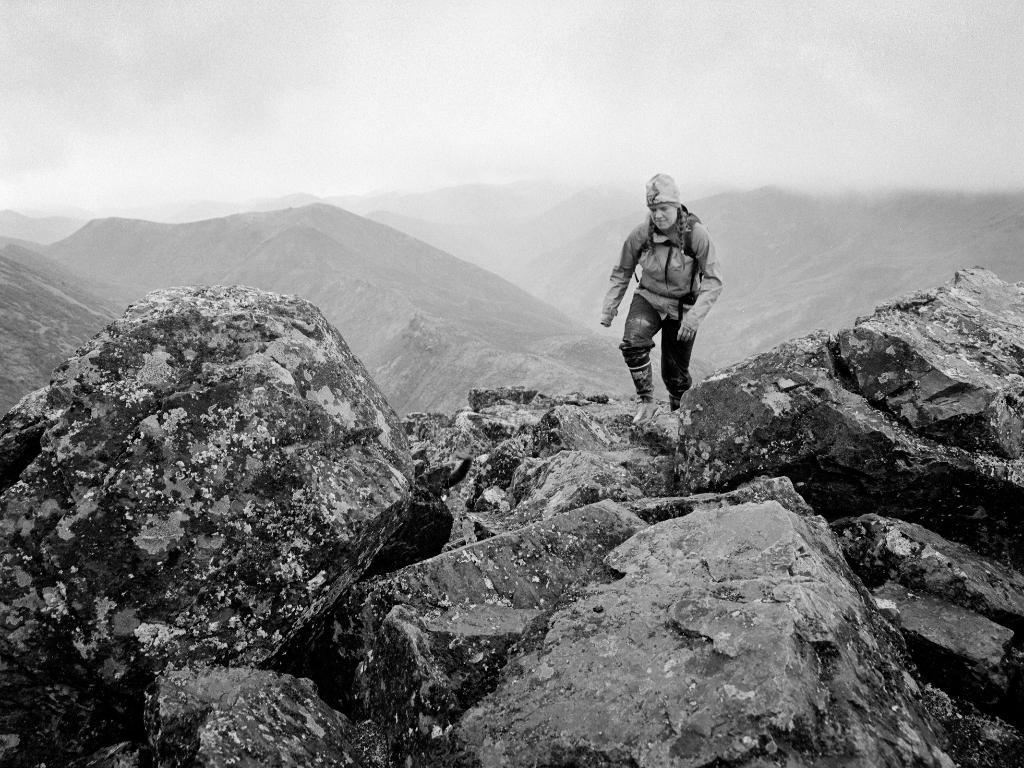What type of natural elements can be seen in the image? There are rocks in the image. What is the man in the image doing? The man is standing in the image. What clothing items is the man wearing? The man is wearing a jacket and cap. What can be seen in the distance in the image? There are hills visible in the background of the image. What is visible above the hills in the image? The sky is visible in the background of the image, and clouds are present in the sky. What type of winter sport is the man participating in the image? The image does not depict any winter sports or activities, and there is no indication that the man is participating in any such activity. What is the size and shape of the man's nose in the image? The image does not provide enough detail to determine the size and shape of the man's nose. 